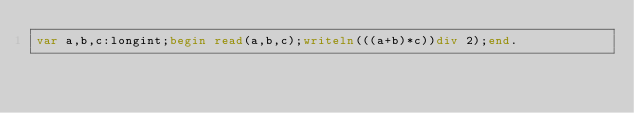Convert code to text. <code><loc_0><loc_0><loc_500><loc_500><_Pascal_>var a,b,c:longint;begin read(a,b,c);writeln(((a+b)*c))div 2);end.</code> 